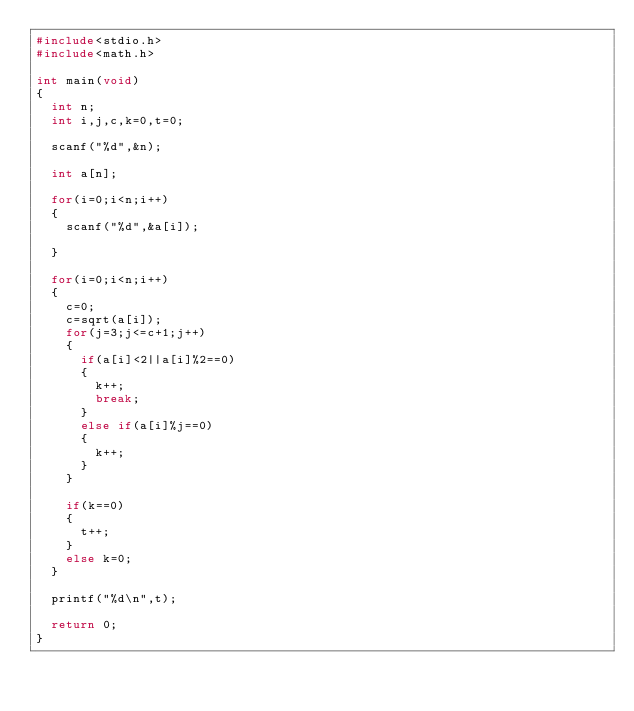<code> <loc_0><loc_0><loc_500><loc_500><_C_>#include<stdio.h>
#include<math.h>

int main(void)
{
	int n;
	int i,j,c,k=0,t=0;
	
	scanf("%d",&n);
	
	int a[n];
	
	for(i=0;i<n;i++)
	{
		scanf("%d",&a[i]);
		
	}
	
	for(i=0;i<n;i++)
	{
		c=0;
		c=sqrt(a[i]);
		for(j=3;j<=c+1;j++)
		{
			if(a[i]<2||a[i]%2==0)
			{
				k++;
				break;
			}
			else if(a[i]%j==0)
			{
				k++;
			}
		}
		
		if(k==0)
		{
			t++;
		}
		else k=0;
	}
	
	printf("%d\n",t);
	
	return 0;
}
</code> 